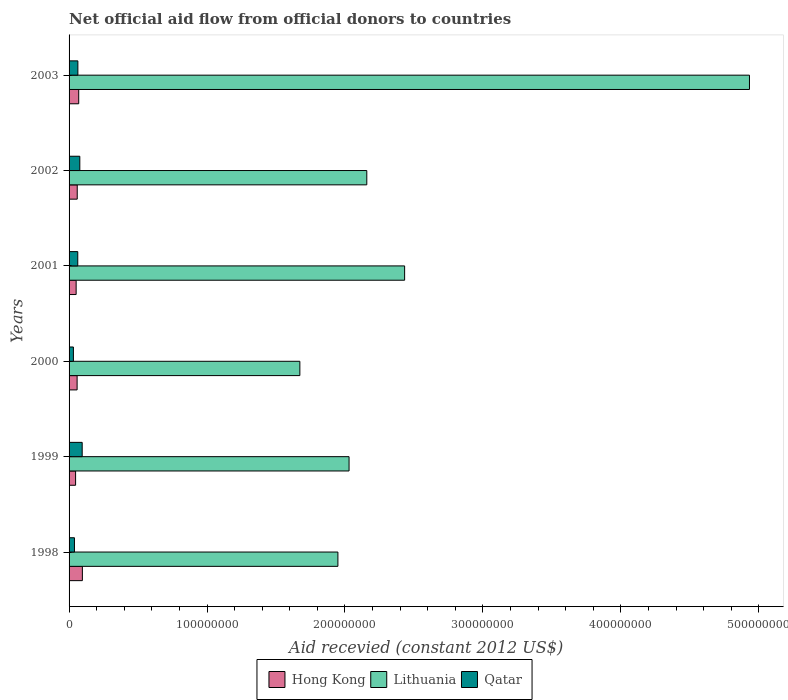How many different coloured bars are there?
Keep it short and to the point. 3. Are the number of bars per tick equal to the number of legend labels?
Your answer should be compact. Yes. How many bars are there on the 4th tick from the top?
Offer a terse response. 3. What is the total aid received in Lithuania in 2003?
Offer a very short reply. 4.93e+08. Across all years, what is the maximum total aid received in Hong Kong?
Your answer should be compact. 9.64e+06. Across all years, what is the minimum total aid received in Lithuania?
Provide a short and direct response. 1.67e+08. What is the total total aid received in Hong Kong in the graph?
Your answer should be very brief. 3.82e+07. What is the difference between the total aid received in Lithuania in 1999 and that in 2000?
Your answer should be very brief. 3.57e+07. What is the difference between the total aid received in Qatar in 1998 and the total aid received in Hong Kong in 2002?
Your answer should be very brief. -2.02e+06. What is the average total aid received in Hong Kong per year?
Your answer should be very brief. 6.37e+06. In the year 1999, what is the difference between the total aid received in Lithuania and total aid received in Hong Kong?
Offer a terse response. 1.98e+08. What is the ratio of the total aid received in Hong Kong in 1999 to that in 2000?
Provide a succinct answer. 0.81. Is the difference between the total aid received in Lithuania in 2000 and 2003 greater than the difference between the total aid received in Hong Kong in 2000 and 2003?
Offer a terse response. No. What is the difference between the highest and the second highest total aid received in Qatar?
Ensure brevity in your answer.  1.72e+06. What is the difference between the highest and the lowest total aid received in Qatar?
Your response must be concise. 6.37e+06. What does the 1st bar from the top in 2003 represents?
Provide a succinct answer. Qatar. What does the 3rd bar from the bottom in 2002 represents?
Provide a succinct answer. Qatar. What is the difference between two consecutive major ticks on the X-axis?
Provide a short and direct response. 1.00e+08. Does the graph contain any zero values?
Ensure brevity in your answer.  No. Does the graph contain grids?
Your answer should be very brief. No. Where does the legend appear in the graph?
Offer a terse response. Bottom center. How are the legend labels stacked?
Offer a terse response. Horizontal. What is the title of the graph?
Offer a terse response. Net official aid flow from official donors to countries. Does "Paraguay" appear as one of the legend labels in the graph?
Offer a very short reply. No. What is the label or title of the X-axis?
Provide a short and direct response. Aid recevied (constant 2012 US$). What is the label or title of the Y-axis?
Your answer should be very brief. Years. What is the Aid recevied (constant 2012 US$) of Hong Kong in 1998?
Your answer should be very brief. 9.64e+06. What is the Aid recevied (constant 2012 US$) of Lithuania in 1998?
Your response must be concise. 1.95e+08. What is the Aid recevied (constant 2012 US$) in Qatar in 1998?
Provide a short and direct response. 3.90e+06. What is the Aid recevied (constant 2012 US$) of Hong Kong in 1999?
Make the answer very short. 4.73e+06. What is the Aid recevied (constant 2012 US$) in Lithuania in 1999?
Keep it short and to the point. 2.03e+08. What is the Aid recevied (constant 2012 US$) of Qatar in 1999?
Your response must be concise. 9.51e+06. What is the Aid recevied (constant 2012 US$) of Hong Kong in 2000?
Provide a succinct answer. 5.83e+06. What is the Aid recevied (constant 2012 US$) in Lithuania in 2000?
Provide a short and direct response. 1.67e+08. What is the Aid recevied (constant 2012 US$) in Qatar in 2000?
Make the answer very short. 3.14e+06. What is the Aid recevied (constant 2012 US$) in Hong Kong in 2001?
Your answer should be very brief. 5.12e+06. What is the Aid recevied (constant 2012 US$) of Lithuania in 2001?
Your answer should be compact. 2.43e+08. What is the Aid recevied (constant 2012 US$) of Qatar in 2001?
Provide a short and direct response. 6.30e+06. What is the Aid recevied (constant 2012 US$) of Hong Kong in 2002?
Make the answer very short. 5.92e+06. What is the Aid recevied (constant 2012 US$) in Lithuania in 2002?
Make the answer very short. 2.16e+08. What is the Aid recevied (constant 2012 US$) of Qatar in 2002?
Provide a succinct answer. 7.79e+06. What is the Aid recevied (constant 2012 US$) of Hong Kong in 2003?
Provide a succinct answer. 6.99e+06. What is the Aid recevied (constant 2012 US$) of Lithuania in 2003?
Your answer should be compact. 4.93e+08. What is the Aid recevied (constant 2012 US$) in Qatar in 2003?
Provide a short and direct response. 6.38e+06. Across all years, what is the maximum Aid recevied (constant 2012 US$) in Hong Kong?
Provide a short and direct response. 9.64e+06. Across all years, what is the maximum Aid recevied (constant 2012 US$) in Lithuania?
Your answer should be compact. 4.93e+08. Across all years, what is the maximum Aid recevied (constant 2012 US$) in Qatar?
Offer a very short reply. 9.51e+06. Across all years, what is the minimum Aid recevied (constant 2012 US$) of Hong Kong?
Provide a short and direct response. 4.73e+06. Across all years, what is the minimum Aid recevied (constant 2012 US$) of Lithuania?
Your response must be concise. 1.67e+08. Across all years, what is the minimum Aid recevied (constant 2012 US$) in Qatar?
Make the answer very short. 3.14e+06. What is the total Aid recevied (constant 2012 US$) of Hong Kong in the graph?
Make the answer very short. 3.82e+07. What is the total Aid recevied (constant 2012 US$) in Lithuania in the graph?
Your answer should be compact. 1.52e+09. What is the total Aid recevied (constant 2012 US$) of Qatar in the graph?
Ensure brevity in your answer.  3.70e+07. What is the difference between the Aid recevied (constant 2012 US$) in Hong Kong in 1998 and that in 1999?
Make the answer very short. 4.91e+06. What is the difference between the Aid recevied (constant 2012 US$) in Lithuania in 1998 and that in 1999?
Make the answer very short. -8.09e+06. What is the difference between the Aid recevied (constant 2012 US$) of Qatar in 1998 and that in 1999?
Keep it short and to the point. -5.61e+06. What is the difference between the Aid recevied (constant 2012 US$) in Hong Kong in 1998 and that in 2000?
Ensure brevity in your answer.  3.81e+06. What is the difference between the Aid recevied (constant 2012 US$) in Lithuania in 1998 and that in 2000?
Offer a very short reply. 2.76e+07. What is the difference between the Aid recevied (constant 2012 US$) in Qatar in 1998 and that in 2000?
Keep it short and to the point. 7.60e+05. What is the difference between the Aid recevied (constant 2012 US$) of Hong Kong in 1998 and that in 2001?
Ensure brevity in your answer.  4.52e+06. What is the difference between the Aid recevied (constant 2012 US$) in Lithuania in 1998 and that in 2001?
Provide a succinct answer. -4.84e+07. What is the difference between the Aid recevied (constant 2012 US$) of Qatar in 1998 and that in 2001?
Keep it short and to the point. -2.40e+06. What is the difference between the Aid recevied (constant 2012 US$) in Hong Kong in 1998 and that in 2002?
Make the answer very short. 3.72e+06. What is the difference between the Aid recevied (constant 2012 US$) of Lithuania in 1998 and that in 2002?
Provide a short and direct response. -2.10e+07. What is the difference between the Aid recevied (constant 2012 US$) in Qatar in 1998 and that in 2002?
Ensure brevity in your answer.  -3.89e+06. What is the difference between the Aid recevied (constant 2012 US$) in Hong Kong in 1998 and that in 2003?
Provide a short and direct response. 2.65e+06. What is the difference between the Aid recevied (constant 2012 US$) in Lithuania in 1998 and that in 2003?
Give a very brief answer. -2.98e+08. What is the difference between the Aid recevied (constant 2012 US$) in Qatar in 1998 and that in 2003?
Offer a very short reply. -2.48e+06. What is the difference between the Aid recevied (constant 2012 US$) in Hong Kong in 1999 and that in 2000?
Provide a succinct answer. -1.10e+06. What is the difference between the Aid recevied (constant 2012 US$) in Lithuania in 1999 and that in 2000?
Keep it short and to the point. 3.57e+07. What is the difference between the Aid recevied (constant 2012 US$) in Qatar in 1999 and that in 2000?
Offer a terse response. 6.37e+06. What is the difference between the Aid recevied (constant 2012 US$) of Hong Kong in 1999 and that in 2001?
Keep it short and to the point. -3.90e+05. What is the difference between the Aid recevied (constant 2012 US$) of Lithuania in 1999 and that in 2001?
Provide a succinct answer. -4.03e+07. What is the difference between the Aid recevied (constant 2012 US$) in Qatar in 1999 and that in 2001?
Make the answer very short. 3.21e+06. What is the difference between the Aid recevied (constant 2012 US$) in Hong Kong in 1999 and that in 2002?
Your answer should be compact. -1.19e+06. What is the difference between the Aid recevied (constant 2012 US$) in Lithuania in 1999 and that in 2002?
Your answer should be compact. -1.29e+07. What is the difference between the Aid recevied (constant 2012 US$) of Qatar in 1999 and that in 2002?
Give a very brief answer. 1.72e+06. What is the difference between the Aid recevied (constant 2012 US$) in Hong Kong in 1999 and that in 2003?
Ensure brevity in your answer.  -2.26e+06. What is the difference between the Aid recevied (constant 2012 US$) of Lithuania in 1999 and that in 2003?
Your answer should be very brief. -2.90e+08. What is the difference between the Aid recevied (constant 2012 US$) of Qatar in 1999 and that in 2003?
Provide a succinct answer. 3.13e+06. What is the difference between the Aid recevied (constant 2012 US$) of Hong Kong in 2000 and that in 2001?
Your answer should be compact. 7.10e+05. What is the difference between the Aid recevied (constant 2012 US$) of Lithuania in 2000 and that in 2001?
Give a very brief answer. -7.60e+07. What is the difference between the Aid recevied (constant 2012 US$) of Qatar in 2000 and that in 2001?
Your answer should be very brief. -3.16e+06. What is the difference between the Aid recevied (constant 2012 US$) in Hong Kong in 2000 and that in 2002?
Your answer should be very brief. -9.00e+04. What is the difference between the Aid recevied (constant 2012 US$) in Lithuania in 2000 and that in 2002?
Provide a succinct answer. -4.85e+07. What is the difference between the Aid recevied (constant 2012 US$) of Qatar in 2000 and that in 2002?
Give a very brief answer. -4.65e+06. What is the difference between the Aid recevied (constant 2012 US$) in Hong Kong in 2000 and that in 2003?
Provide a short and direct response. -1.16e+06. What is the difference between the Aid recevied (constant 2012 US$) in Lithuania in 2000 and that in 2003?
Give a very brief answer. -3.26e+08. What is the difference between the Aid recevied (constant 2012 US$) of Qatar in 2000 and that in 2003?
Ensure brevity in your answer.  -3.24e+06. What is the difference between the Aid recevied (constant 2012 US$) in Hong Kong in 2001 and that in 2002?
Offer a very short reply. -8.00e+05. What is the difference between the Aid recevied (constant 2012 US$) of Lithuania in 2001 and that in 2002?
Offer a very short reply. 2.74e+07. What is the difference between the Aid recevied (constant 2012 US$) of Qatar in 2001 and that in 2002?
Give a very brief answer. -1.49e+06. What is the difference between the Aid recevied (constant 2012 US$) in Hong Kong in 2001 and that in 2003?
Your answer should be very brief. -1.87e+06. What is the difference between the Aid recevied (constant 2012 US$) in Lithuania in 2001 and that in 2003?
Provide a succinct answer. -2.50e+08. What is the difference between the Aid recevied (constant 2012 US$) in Hong Kong in 2002 and that in 2003?
Give a very brief answer. -1.07e+06. What is the difference between the Aid recevied (constant 2012 US$) of Lithuania in 2002 and that in 2003?
Provide a short and direct response. -2.77e+08. What is the difference between the Aid recevied (constant 2012 US$) in Qatar in 2002 and that in 2003?
Your answer should be very brief. 1.41e+06. What is the difference between the Aid recevied (constant 2012 US$) of Hong Kong in 1998 and the Aid recevied (constant 2012 US$) of Lithuania in 1999?
Your response must be concise. -1.93e+08. What is the difference between the Aid recevied (constant 2012 US$) of Hong Kong in 1998 and the Aid recevied (constant 2012 US$) of Qatar in 1999?
Your answer should be very brief. 1.30e+05. What is the difference between the Aid recevied (constant 2012 US$) in Lithuania in 1998 and the Aid recevied (constant 2012 US$) in Qatar in 1999?
Offer a very short reply. 1.85e+08. What is the difference between the Aid recevied (constant 2012 US$) of Hong Kong in 1998 and the Aid recevied (constant 2012 US$) of Lithuania in 2000?
Offer a very short reply. -1.58e+08. What is the difference between the Aid recevied (constant 2012 US$) in Hong Kong in 1998 and the Aid recevied (constant 2012 US$) in Qatar in 2000?
Your answer should be compact. 6.50e+06. What is the difference between the Aid recevied (constant 2012 US$) of Lithuania in 1998 and the Aid recevied (constant 2012 US$) of Qatar in 2000?
Ensure brevity in your answer.  1.92e+08. What is the difference between the Aid recevied (constant 2012 US$) in Hong Kong in 1998 and the Aid recevied (constant 2012 US$) in Lithuania in 2001?
Ensure brevity in your answer.  -2.34e+08. What is the difference between the Aid recevied (constant 2012 US$) of Hong Kong in 1998 and the Aid recevied (constant 2012 US$) of Qatar in 2001?
Your answer should be compact. 3.34e+06. What is the difference between the Aid recevied (constant 2012 US$) of Lithuania in 1998 and the Aid recevied (constant 2012 US$) of Qatar in 2001?
Keep it short and to the point. 1.89e+08. What is the difference between the Aid recevied (constant 2012 US$) of Hong Kong in 1998 and the Aid recevied (constant 2012 US$) of Lithuania in 2002?
Provide a short and direct response. -2.06e+08. What is the difference between the Aid recevied (constant 2012 US$) in Hong Kong in 1998 and the Aid recevied (constant 2012 US$) in Qatar in 2002?
Give a very brief answer. 1.85e+06. What is the difference between the Aid recevied (constant 2012 US$) in Lithuania in 1998 and the Aid recevied (constant 2012 US$) in Qatar in 2002?
Ensure brevity in your answer.  1.87e+08. What is the difference between the Aid recevied (constant 2012 US$) of Hong Kong in 1998 and the Aid recevied (constant 2012 US$) of Lithuania in 2003?
Provide a short and direct response. -4.84e+08. What is the difference between the Aid recevied (constant 2012 US$) of Hong Kong in 1998 and the Aid recevied (constant 2012 US$) of Qatar in 2003?
Provide a short and direct response. 3.26e+06. What is the difference between the Aid recevied (constant 2012 US$) of Lithuania in 1998 and the Aid recevied (constant 2012 US$) of Qatar in 2003?
Provide a short and direct response. 1.88e+08. What is the difference between the Aid recevied (constant 2012 US$) of Hong Kong in 1999 and the Aid recevied (constant 2012 US$) of Lithuania in 2000?
Keep it short and to the point. -1.63e+08. What is the difference between the Aid recevied (constant 2012 US$) of Hong Kong in 1999 and the Aid recevied (constant 2012 US$) of Qatar in 2000?
Your answer should be compact. 1.59e+06. What is the difference between the Aid recevied (constant 2012 US$) in Lithuania in 1999 and the Aid recevied (constant 2012 US$) in Qatar in 2000?
Give a very brief answer. 2.00e+08. What is the difference between the Aid recevied (constant 2012 US$) of Hong Kong in 1999 and the Aid recevied (constant 2012 US$) of Lithuania in 2001?
Your answer should be compact. -2.39e+08. What is the difference between the Aid recevied (constant 2012 US$) of Hong Kong in 1999 and the Aid recevied (constant 2012 US$) of Qatar in 2001?
Offer a very short reply. -1.57e+06. What is the difference between the Aid recevied (constant 2012 US$) in Lithuania in 1999 and the Aid recevied (constant 2012 US$) in Qatar in 2001?
Your response must be concise. 1.97e+08. What is the difference between the Aid recevied (constant 2012 US$) of Hong Kong in 1999 and the Aid recevied (constant 2012 US$) of Lithuania in 2002?
Offer a very short reply. -2.11e+08. What is the difference between the Aid recevied (constant 2012 US$) in Hong Kong in 1999 and the Aid recevied (constant 2012 US$) in Qatar in 2002?
Offer a very short reply. -3.06e+06. What is the difference between the Aid recevied (constant 2012 US$) of Lithuania in 1999 and the Aid recevied (constant 2012 US$) of Qatar in 2002?
Your answer should be very brief. 1.95e+08. What is the difference between the Aid recevied (constant 2012 US$) of Hong Kong in 1999 and the Aid recevied (constant 2012 US$) of Lithuania in 2003?
Make the answer very short. -4.89e+08. What is the difference between the Aid recevied (constant 2012 US$) of Hong Kong in 1999 and the Aid recevied (constant 2012 US$) of Qatar in 2003?
Your answer should be compact. -1.65e+06. What is the difference between the Aid recevied (constant 2012 US$) in Lithuania in 1999 and the Aid recevied (constant 2012 US$) in Qatar in 2003?
Your response must be concise. 1.97e+08. What is the difference between the Aid recevied (constant 2012 US$) of Hong Kong in 2000 and the Aid recevied (constant 2012 US$) of Lithuania in 2001?
Your answer should be compact. -2.37e+08. What is the difference between the Aid recevied (constant 2012 US$) in Hong Kong in 2000 and the Aid recevied (constant 2012 US$) in Qatar in 2001?
Make the answer very short. -4.70e+05. What is the difference between the Aid recevied (constant 2012 US$) in Lithuania in 2000 and the Aid recevied (constant 2012 US$) in Qatar in 2001?
Offer a very short reply. 1.61e+08. What is the difference between the Aid recevied (constant 2012 US$) in Hong Kong in 2000 and the Aid recevied (constant 2012 US$) in Lithuania in 2002?
Offer a very short reply. -2.10e+08. What is the difference between the Aid recevied (constant 2012 US$) of Hong Kong in 2000 and the Aid recevied (constant 2012 US$) of Qatar in 2002?
Your answer should be very brief. -1.96e+06. What is the difference between the Aid recevied (constant 2012 US$) in Lithuania in 2000 and the Aid recevied (constant 2012 US$) in Qatar in 2002?
Your response must be concise. 1.60e+08. What is the difference between the Aid recevied (constant 2012 US$) of Hong Kong in 2000 and the Aid recevied (constant 2012 US$) of Lithuania in 2003?
Keep it short and to the point. -4.87e+08. What is the difference between the Aid recevied (constant 2012 US$) of Hong Kong in 2000 and the Aid recevied (constant 2012 US$) of Qatar in 2003?
Your response must be concise. -5.50e+05. What is the difference between the Aid recevied (constant 2012 US$) of Lithuania in 2000 and the Aid recevied (constant 2012 US$) of Qatar in 2003?
Make the answer very short. 1.61e+08. What is the difference between the Aid recevied (constant 2012 US$) in Hong Kong in 2001 and the Aid recevied (constant 2012 US$) in Lithuania in 2002?
Provide a succinct answer. -2.11e+08. What is the difference between the Aid recevied (constant 2012 US$) of Hong Kong in 2001 and the Aid recevied (constant 2012 US$) of Qatar in 2002?
Ensure brevity in your answer.  -2.67e+06. What is the difference between the Aid recevied (constant 2012 US$) in Lithuania in 2001 and the Aid recevied (constant 2012 US$) in Qatar in 2002?
Offer a terse response. 2.35e+08. What is the difference between the Aid recevied (constant 2012 US$) in Hong Kong in 2001 and the Aid recevied (constant 2012 US$) in Lithuania in 2003?
Provide a short and direct response. -4.88e+08. What is the difference between the Aid recevied (constant 2012 US$) of Hong Kong in 2001 and the Aid recevied (constant 2012 US$) of Qatar in 2003?
Offer a very short reply. -1.26e+06. What is the difference between the Aid recevied (constant 2012 US$) in Lithuania in 2001 and the Aid recevied (constant 2012 US$) in Qatar in 2003?
Make the answer very short. 2.37e+08. What is the difference between the Aid recevied (constant 2012 US$) of Hong Kong in 2002 and the Aid recevied (constant 2012 US$) of Lithuania in 2003?
Your answer should be very brief. -4.87e+08. What is the difference between the Aid recevied (constant 2012 US$) in Hong Kong in 2002 and the Aid recevied (constant 2012 US$) in Qatar in 2003?
Your answer should be very brief. -4.60e+05. What is the difference between the Aid recevied (constant 2012 US$) in Lithuania in 2002 and the Aid recevied (constant 2012 US$) in Qatar in 2003?
Keep it short and to the point. 2.09e+08. What is the average Aid recevied (constant 2012 US$) in Hong Kong per year?
Make the answer very short. 6.37e+06. What is the average Aid recevied (constant 2012 US$) in Lithuania per year?
Your response must be concise. 2.53e+08. What is the average Aid recevied (constant 2012 US$) in Qatar per year?
Ensure brevity in your answer.  6.17e+06. In the year 1998, what is the difference between the Aid recevied (constant 2012 US$) in Hong Kong and Aid recevied (constant 2012 US$) in Lithuania?
Make the answer very short. -1.85e+08. In the year 1998, what is the difference between the Aid recevied (constant 2012 US$) in Hong Kong and Aid recevied (constant 2012 US$) in Qatar?
Make the answer very short. 5.74e+06. In the year 1998, what is the difference between the Aid recevied (constant 2012 US$) in Lithuania and Aid recevied (constant 2012 US$) in Qatar?
Ensure brevity in your answer.  1.91e+08. In the year 1999, what is the difference between the Aid recevied (constant 2012 US$) of Hong Kong and Aid recevied (constant 2012 US$) of Lithuania?
Your answer should be compact. -1.98e+08. In the year 1999, what is the difference between the Aid recevied (constant 2012 US$) of Hong Kong and Aid recevied (constant 2012 US$) of Qatar?
Provide a short and direct response. -4.78e+06. In the year 1999, what is the difference between the Aid recevied (constant 2012 US$) in Lithuania and Aid recevied (constant 2012 US$) in Qatar?
Your answer should be compact. 1.93e+08. In the year 2000, what is the difference between the Aid recevied (constant 2012 US$) in Hong Kong and Aid recevied (constant 2012 US$) in Lithuania?
Your response must be concise. -1.61e+08. In the year 2000, what is the difference between the Aid recevied (constant 2012 US$) of Hong Kong and Aid recevied (constant 2012 US$) of Qatar?
Give a very brief answer. 2.69e+06. In the year 2000, what is the difference between the Aid recevied (constant 2012 US$) in Lithuania and Aid recevied (constant 2012 US$) in Qatar?
Your response must be concise. 1.64e+08. In the year 2001, what is the difference between the Aid recevied (constant 2012 US$) in Hong Kong and Aid recevied (constant 2012 US$) in Lithuania?
Keep it short and to the point. -2.38e+08. In the year 2001, what is the difference between the Aid recevied (constant 2012 US$) in Hong Kong and Aid recevied (constant 2012 US$) in Qatar?
Keep it short and to the point. -1.18e+06. In the year 2001, what is the difference between the Aid recevied (constant 2012 US$) of Lithuania and Aid recevied (constant 2012 US$) of Qatar?
Provide a short and direct response. 2.37e+08. In the year 2002, what is the difference between the Aid recevied (constant 2012 US$) in Hong Kong and Aid recevied (constant 2012 US$) in Lithuania?
Ensure brevity in your answer.  -2.10e+08. In the year 2002, what is the difference between the Aid recevied (constant 2012 US$) in Hong Kong and Aid recevied (constant 2012 US$) in Qatar?
Give a very brief answer. -1.87e+06. In the year 2002, what is the difference between the Aid recevied (constant 2012 US$) in Lithuania and Aid recevied (constant 2012 US$) in Qatar?
Keep it short and to the point. 2.08e+08. In the year 2003, what is the difference between the Aid recevied (constant 2012 US$) of Hong Kong and Aid recevied (constant 2012 US$) of Lithuania?
Provide a short and direct response. -4.86e+08. In the year 2003, what is the difference between the Aid recevied (constant 2012 US$) in Lithuania and Aid recevied (constant 2012 US$) in Qatar?
Your answer should be very brief. 4.87e+08. What is the ratio of the Aid recevied (constant 2012 US$) in Hong Kong in 1998 to that in 1999?
Provide a short and direct response. 2.04. What is the ratio of the Aid recevied (constant 2012 US$) of Lithuania in 1998 to that in 1999?
Your answer should be very brief. 0.96. What is the ratio of the Aid recevied (constant 2012 US$) of Qatar in 1998 to that in 1999?
Offer a very short reply. 0.41. What is the ratio of the Aid recevied (constant 2012 US$) in Hong Kong in 1998 to that in 2000?
Offer a very short reply. 1.65. What is the ratio of the Aid recevied (constant 2012 US$) in Lithuania in 1998 to that in 2000?
Your answer should be very brief. 1.16. What is the ratio of the Aid recevied (constant 2012 US$) of Qatar in 1998 to that in 2000?
Your answer should be very brief. 1.24. What is the ratio of the Aid recevied (constant 2012 US$) in Hong Kong in 1998 to that in 2001?
Provide a succinct answer. 1.88. What is the ratio of the Aid recevied (constant 2012 US$) of Lithuania in 1998 to that in 2001?
Your answer should be compact. 0.8. What is the ratio of the Aid recevied (constant 2012 US$) of Qatar in 1998 to that in 2001?
Give a very brief answer. 0.62. What is the ratio of the Aid recevied (constant 2012 US$) in Hong Kong in 1998 to that in 2002?
Your answer should be very brief. 1.63. What is the ratio of the Aid recevied (constant 2012 US$) in Lithuania in 1998 to that in 2002?
Keep it short and to the point. 0.9. What is the ratio of the Aid recevied (constant 2012 US$) in Qatar in 1998 to that in 2002?
Your response must be concise. 0.5. What is the ratio of the Aid recevied (constant 2012 US$) in Hong Kong in 1998 to that in 2003?
Make the answer very short. 1.38. What is the ratio of the Aid recevied (constant 2012 US$) in Lithuania in 1998 to that in 2003?
Your response must be concise. 0.4. What is the ratio of the Aid recevied (constant 2012 US$) in Qatar in 1998 to that in 2003?
Provide a succinct answer. 0.61. What is the ratio of the Aid recevied (constant 2012 US$) of Hong Kong in 1999 to that in 2000?
Offer a very short reply. 0.81. What is the ratio of the Aid recevied (constant 2012 US$) of Lithuania in 1999 to that in 2000?
Offer a terse response. 1.21. What is the ratio of the Aid recevied (constant 2012 US$) in Qatar in 1999 to that in 2000?
Keep it short and to the point. 3.03. What is the ratio of the Aid recevied (constant 2012 US$) in Hong Kong in 1999 to that in 2001?
Keep it short and to the point. 0.92. What is the ratio of the Aid recevied (constant 2012 US$) in Lithuania in 1999 to that in 2001?
Ensure brevity in your answer.  0.83. What is the ratio of the Aid recevied (constant 2012 US$) in Qatar in 1999 to that in 2001?
Ensure brevity in your answer.  1.51. What is the ratio of the Aid recevied (constant 2012 US$) of Hong Kong in 1999 to that in 2002?
Your answer should be compact. 0.8. What is the ratio of the Aid recevied (constant 2012 US$) in Lithuania in 1999 to that in 2002?
Your answer should be very brief. 0.94. What is the ratio of the Aid recevied (constant 2012 US$) in Qatar in 1999 to that in 2002?
Offer a terse response. 1.22. What is the ratio of the Aid recevied (constant 2012 US$) of Hong Kong in 1999 to that in 2003?
Give a very brief answer. 0.68. What is the ratio of the Aid recevied (constant 2012 US$) of Lithuania in 1999 to that in 2003?
Offer a very short reply. 0.41. What is the ratio of the Aid recevied (constant 2012 US$) in Qatar in 1999 to that in 2003?
Give a very brief answer. 1.49. What is the ratio of the Aid recevied (constant 2012 US$) in Hong Kong in 2000 to that in 2001?
Provide a succinct answer. 1.14. What is the ratio of the Aid recevied (constant 2012 US$) of Lithuania in 2000 to that in 2001?
Make the answer very short. 0.69. What is the ratio of the Aid recevied (constant 2012 US$) of Qatar in 2000 to that in 2001?
Ensure brevity in your answer.  0.5. What is the ratio of the Aid recevied (constant 2012 US$) of Lithuania in 2000 to that in 2002?
Offer a very short reply. 0.78. What is the ratio of the Aid recevied (constant 2012 US$) of Qatar in 2000 to that in 2002?
Your response must be concise. 0.4. What is the ratio of the Aid recevied (constant 2012 US$) of Hong Kong in 2000 to that in 2003?
Provide a short and direct response. 0.83. What is the ratio of the Aid recevied (constant 2012 US$) of Lithuania in 2000 to that in 2003?
Your answer should be compact. 0.34. What is the ratio of the Aid recevied (constant 2012 US$) of Qatar in 2000 to that in 2003?
Provide a succinct answer. 0.49. What is the ratio of the Aid recevied (constant 2012 US$) of Hong Kong in 2001 to that in 2002?
Offer a terse response. 0.86. What is the ratio of the Aid recevied (constant 2012 US$) in Lithuania in 2001 to that in 2002?
Offer a terse response. 1.13. What is the ratio of the Aid recevied (constant 2012 US$) in Qatar in 2001 to that in 2002?
Provide a succinct answer. 0.81. What is the ratio of the Aid recevied (constant 2012 US$) in Hong Kong in 2001 to that in 2003?
Provide a short and direct response. 0.73. What is the ratio of the Aid recevied (constant 2012 US$) of Lithuania in 2001 to that in 2003?
Ensure brevity in your answer.  0.49. What is the ratio of the Aid recevied (constant 2012 US$) of Qatar in 2001 to that in 2003?
Provide a short and direct response. 0.99. What is the ratio of the Aid recevied (constant 2012 US$) in Hong Kong in 2002 to that in 2003?
Make the answer very short. 0.85. What is the ratio of the Aid recevied (constant 2012 US$) of Lithuania in 2002 to that in 2003?
Give a very brief answer. 0.44. What is the ratio of the Aid recevied (constant 2012 US$) of Qatar in 2002 to that in 2003?
Make the answer very short. 1.22. What is the difference between the highest and the second highest Aid recevied (constant 2012 US$) in Hong Kong?
Provide a succinct answer. 2.65e+06. What is the difference between the highest and the second highest Aid recevied (constant 2012 US$) in Lithuania?
Provide a succinct answer. 2.50e+08. What is the difference between the highest and the second highest Aid recevied (constant 2012 US$) in Qatar?
Give a very brief answer. 1.72e+06. What is the difference between the highest and the lowest Aid recevied (constant 2012 US$) of Hong Kong?
Offer a very short reply. 4.91e+06. What is the difference between the highest and the lowest Aid recevied (constant 2012 US$) of Lithuania?
Keep it short and to the point. 3.26e+08. What is the difference between the highest and the lowest Aid recevied (constant 2012 US$) of Qatar?
Your answer should be compact. 6.37e+06. 